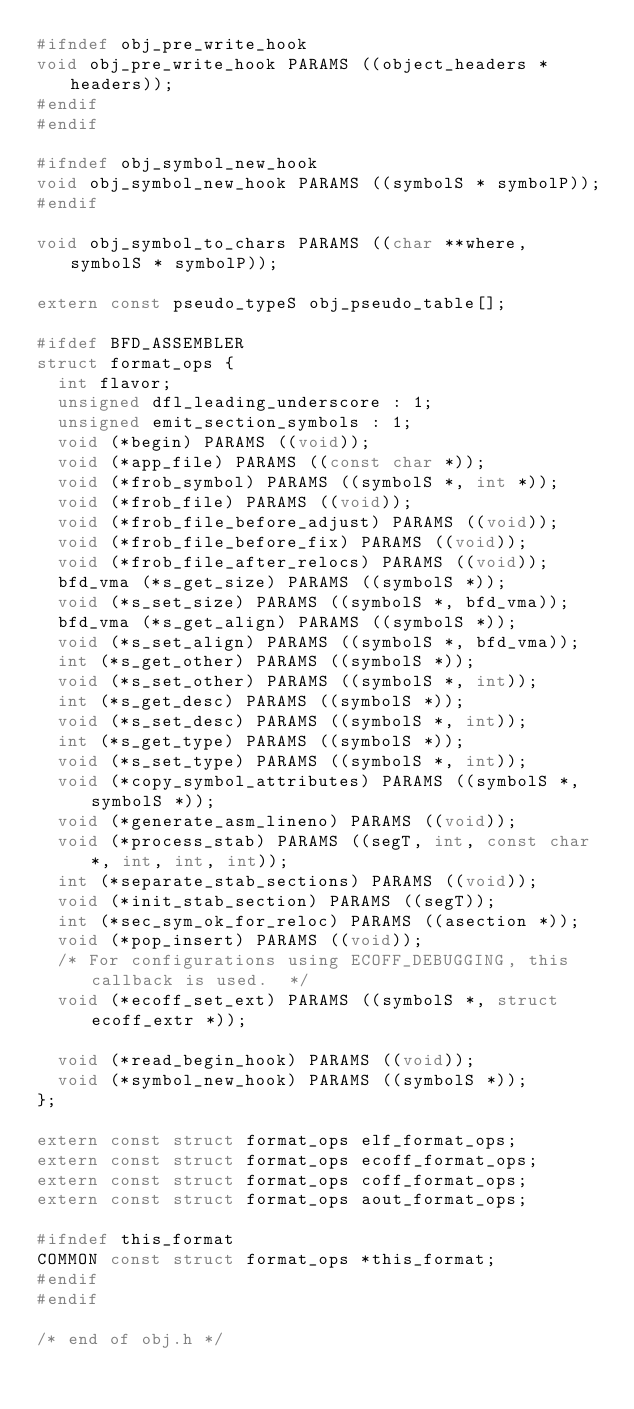<code> <loc_0><loc_0><loc_500><loc_500><_C_>#ifndef obj_pre_write_hook
void obj_pre_write_hook PARAMS ((object_headers * headers));
#endif
#endif

#ifndef obj_symbol_new_hook
void obj_symbol_new_hook PARAMS ((symbolS * symbolP));
#endif

void obj_symbol_to_chars PARAMS ((char **where, symbolS * symbolP));

extern const pseudo_typeS obj_pseudo_table[];

#ifdef BFD_ASSEMBLER
struct format_ops {
  int flavor;
  unsigned dfl_leading_underscore : 1;
  unsigned emit_section_symbols : 1;
  void (*begin) PARAMS ((void));
  void (*app_file) PARAMS ((const char *));
  void (*frob_symbol) PARAMS ((symbolS *, int *));
  void (*frob_file) PARAMS ((void));
  void (*frob_file_before_adjust) PARAMS ((void));
  void (*frob_file_before_fix) PARAMS ((void));
  void (*frob_file_after_relocs) PARAMS ((void));
  bfd_vma (*s_get_size) PARAMS ((symbolS *));
  void (*s_set_size) PARAMS ((symbolS *, bfd_vma));
  bfd_vma (*s_get_align) PARAMS ((symbolS *));
  void (*s_set_align) PARAMS ((symbolS *, bfd_vma));
  int (*s_get_other) PARAMS ((symbolS *));
  void (*s_set_other) PARAMS ((symbolS *, int));
  int (*s_get_desc) PARAMS ((symbolS *));
  void (*s_set_desc) PARAMS ((symbolS *, int));
  int (*s_get_type) PARAMS ((symbolS *));
  void (*s_set_type) PARAMS ((symbolS *, int));
  void (*copy_symbol_attributes) PARAMS ((symbolS *, symbolS *));
  void (*generate_asm_lineno) PARAMS ((void));
  void (*process_stab) PARAMS ((segT, int, const char *, int, int, int));
  int (*separate_stab_sections) PARAMS ((void));
  void (*init_stab_section) PARAMS ((segT));
  int (*sec_sym_ok_for_reloc) PARAMS ((asection *));
  void (*pop_insert) PARAMS ((void));
  /* For configurations using ECOFF_DEBUGGING, this callback is used.  */
  void (*ecoff_set_ext) PARAMS ((symbolS *, struct ecoff_extr *));

  void (*read_begin_hook) PARAMS ((void));
  void (*symbol_new_hook) PARAMS ((symbolS *));
};

extern const struct format_ops elf_format_ops;
extern const struct format_ops ecoff_format_ops;
extern const struct format_ops coff_format_ops;
extern const struct format_ops aout_format_ops;

#ifndef this_format
COMMON const struct format_ops *this_format;
#endif
#endif

/* end of obj.h */
</code> 